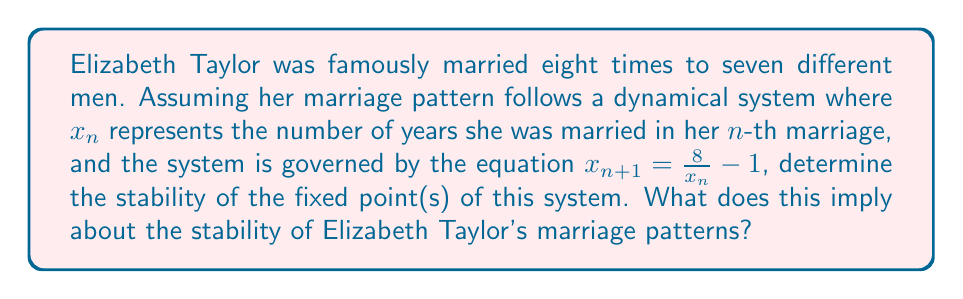What is the answer to this math problem? 1. Find the fixed point(s):
   At a fixed point, $x_{n+1} = x_n = x^*$
   $$x^* = \frac{8}{x^*} - 1$$
   $$x^{*2} + x^* - 8 = 0$$
   Using the quadratic formula:
   $$x^* = \frac{-1 \pm \sqrt{1 + 32}}{2} = \frac{-1 \pm \sqrt{33}}{2}$$
   The positive solution is $x^* = \frac{-1 + \sqrt{33}}{2} \approx 2.372$ years.

2. Determine stability:
   The stability is determined by $|f'(x^*)|$, where $f(x) = \frac{8}{x} - 1$
   $$f'(x) = -\frac{8}{x^2}$$
   $$|f'(x^*)| = \left|\frac{8}{(\frac{-1 + \sqrt{33}}{2})^2}\right| \approx 1.421$$

3. Interpret results:
   Since $|f'(x^*)| > 1$, the fixed point is unstable.
   This implies that Elizabeth Taylor's marriage durations would not converge to a stable value but would oscillate or diverge from the fixed point of approximately 2.372 years.
Answer: Unstable fixed point at $x^* = \frac{-1 + \sqrt{33}}{2} \approx 2.372$ years; implies unstable marriage patterns. 